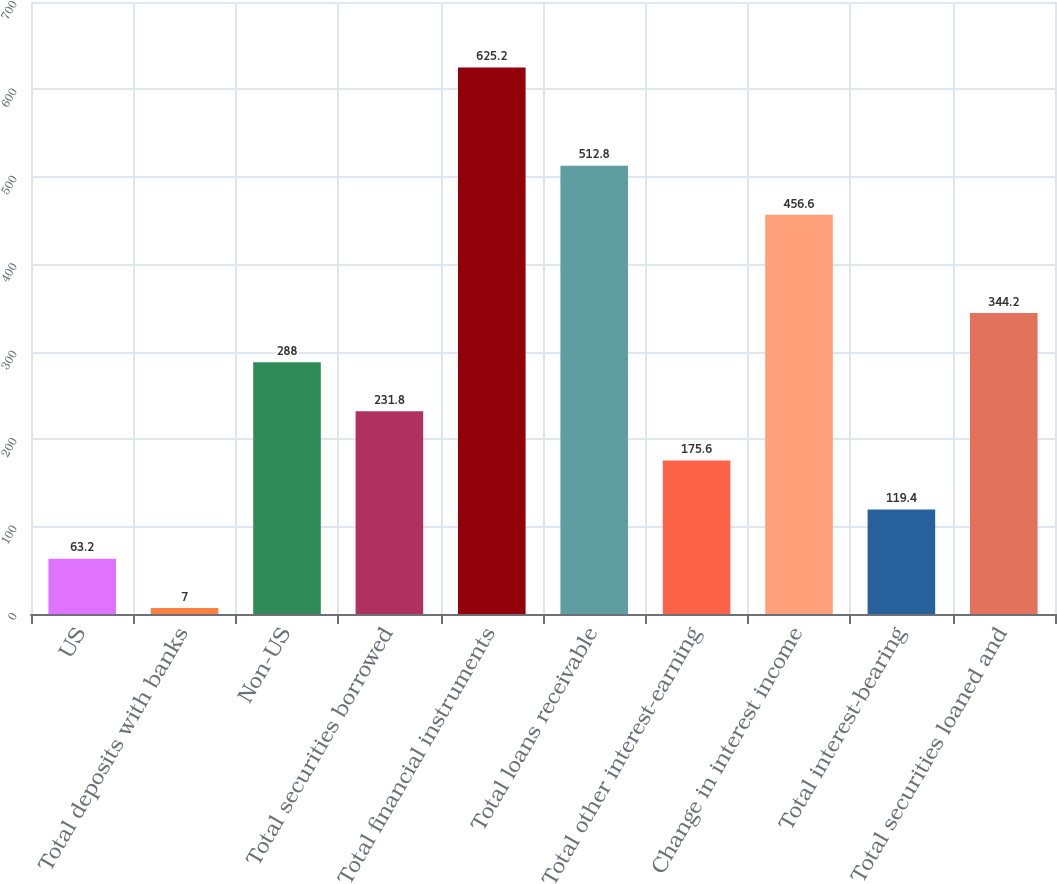<chart> <loc_0><loc_0><loc_500><loc_500><bar_chart><fcel>US<fcel>Total deposits with banks<fcel>Non-US<fcel>Total securities borrowed<fcel>Total financial instruments<fcel>Total loans receivable<fcel>Total other interest-earning<fcel>Change in interest income<fcel>Total interest-bearing<fcel>Total securities loaned and<nl><fcel>63.2<fcel>7<fcel>288<fcel>231.8<fcel>625.2<fcel>512.8<fcel>175.6<fcel>456.6<fcel>119.4<fcel>344.2<nl></chart> 